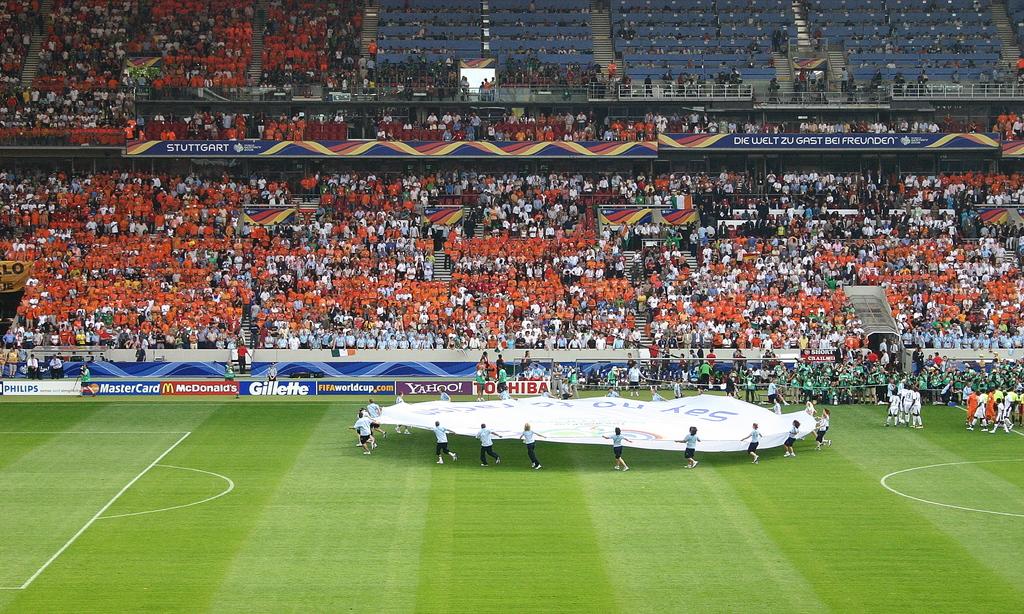What credit card is advertised?
Your answer should be very brief. Mastercard. What razor brand is on a banner?
Provide a succinct answer. Gillette. 